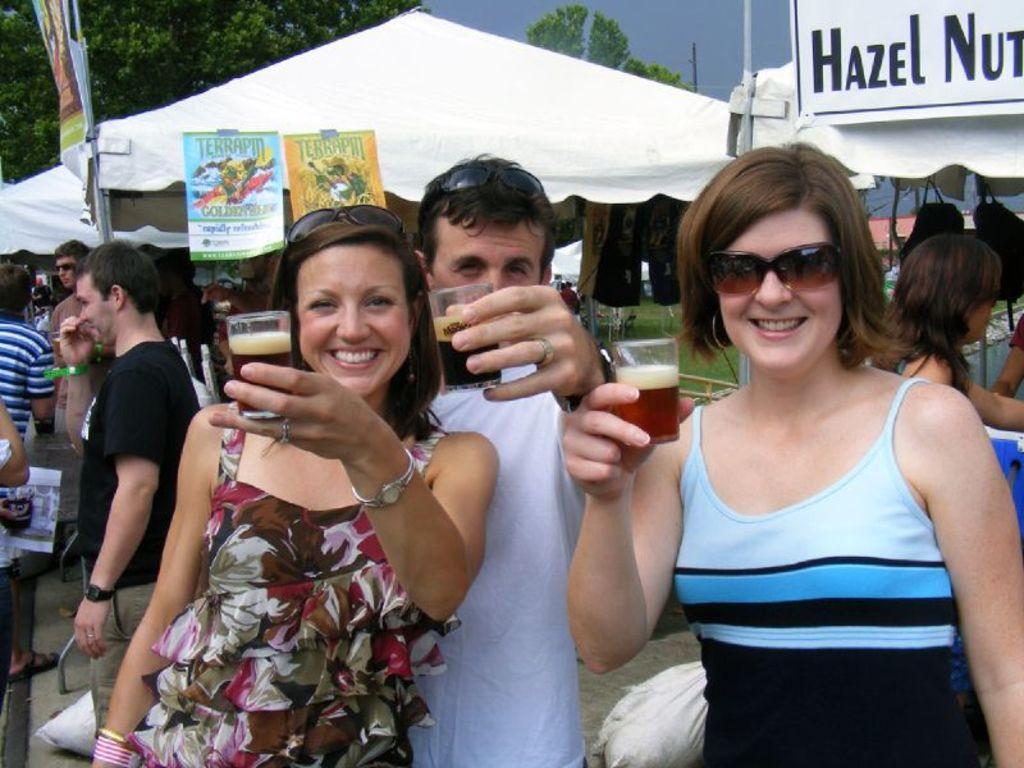In one or two sentences, can you explain what this image depicts? In this image we can see persons standing on the ground and holding glass tumblers in their hands. In the background we can see advertisements, tents, trees and sky. 